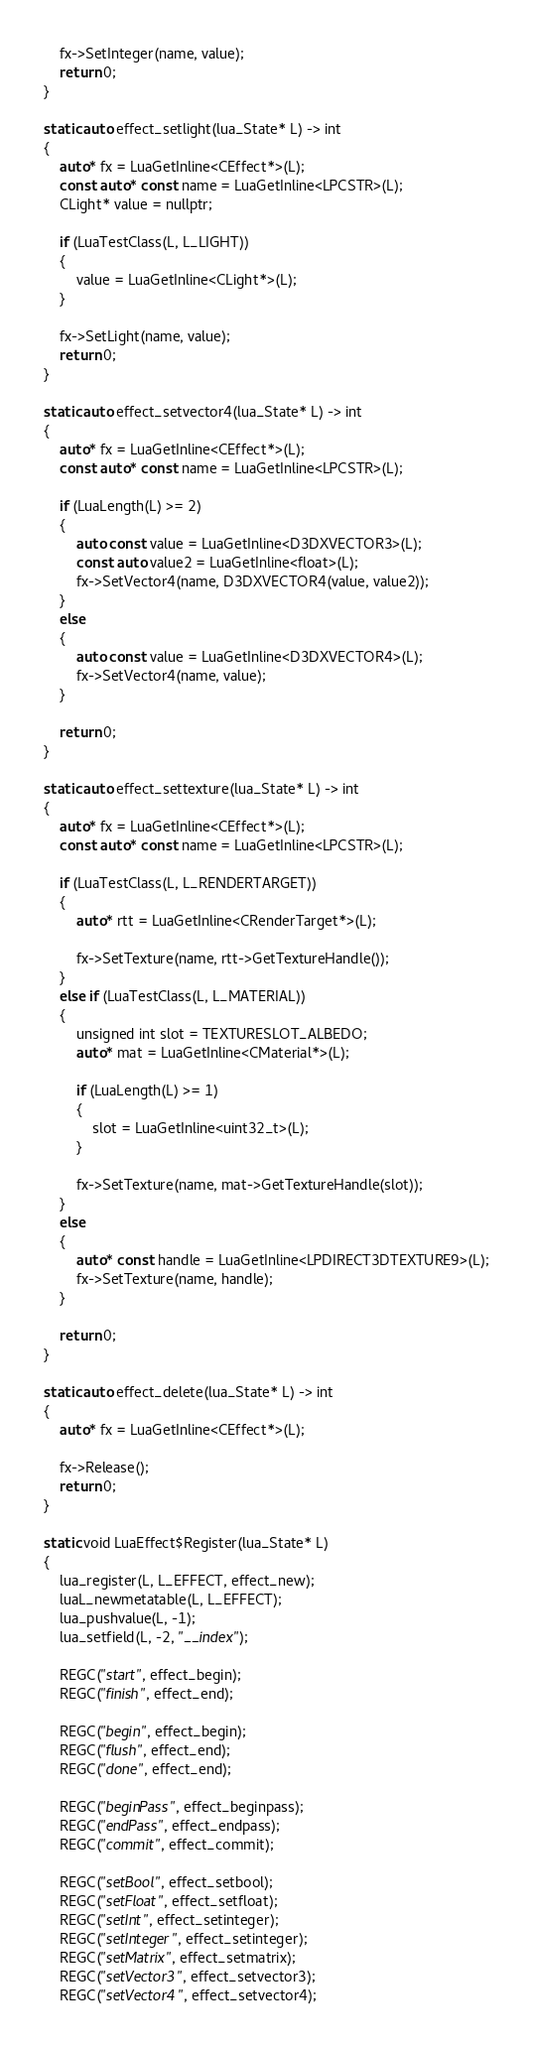Convert code to text. <code><loc_0><loc_0><loc_500><loc_500><_C_>
    fx->SetInteger(name, value);
    return 0;
}

static auto effect_setlight(lua_State* L) -> int
{
    auto* fx = LuaGetInline<CEffect*>(L);
    const auto* const name = LuaGetInline<LPCSTR>(L);
    CLight* value = nullptr;

    if (LuaTestClass(L, L_LIGHT))
    {
        value = LuaGetInline<CLight*>(L);
    }

    fx->SetLight(name, value);
    return 0;
}

static auto effect_setvector4(lua_State* L) -> int
{
    auto* fx = LuaGetInline<CEffect*>(L);
    const auto* const name = LuaGetInline<LPCSTR>(L);

    if (LuaLength(L) >= 2)
    {
        auto const value = LuaGetInline<D3DXVECTOR3>(L);
        const auto value2 = LuaGetInline<float>(L);
        fx->SetVector4(name, D3DXVECTOR4(value, value2));
    }
    else
    {
        auto const value = LuaGetInline<D3DXVECTOR4>(L);
        fx->SetVector4(name, value);
    }

    return 0;
}

static auto effect_settexture(lua_State* L) -> int
{
    auto* fx = LuaGetInline<CEffect*>(L);
    const auto* const name = LuaGetInline<LPCSTR>(L);

    if (LuaTestClass(L, L_RENDERTARGET))
    {
        auto* rtt = LuaGetInline<CRenderTarget*>(L);

        fx->SetTexture(name, rtt->GetTextureHandle());
    }
    else if (LuaTestClass(L, L_MATERIAL))
    {
        unsigned int slot = TEXTURESLOT_ALBEDO;
        auto* mat = LuaGetInline<CMaterial*>(L);

        if (LuaLength(L) >= 1)
        {
            slot = LuaGetInline<uint32_t>(L);
        }

        fx->SetTexture(name, mat->GetTextureHandle(slot));
    }
    else
    {
        auto* const handle = LuaGetInline<LPDIRECT3DTEXTURE9>(L);
        fx->SetTexture(name, handle);
    }

    return 0;
}

static auto effect_delete(lua_State* L) -> int
{
    auto* fx = LuaGetInline<CEffect*>(L);

    fx->Release();
    return 0;
}

static void LuaEffect$Register(lua_State* L)
{
    lua_register(L, L_EFFECT, effect_new);
    luaL_newmetatable(L, L_EFFECT);
    lua_pushvalue(L, -1);
    lua_setfield(L, -2, "__index");

    REGC("start", effect_begin);
    REGC("finish", effect_end);

    REGC("begin", effect_begin);
    REGC("flush", effect_end);
    REGC("done", effect_end);

    REGC("beginPass", effect_beginpass);
    REGC("endPass", effect_endpass);
    REGC("commit", effect_commit);

    REGC("setBool", effect_setbool);
    REGC("setFloat", effect_setfloat);
    REGC("setInt", effect_setinteger);
    REGC("setInteger", effect_setinteger);
    REGC("setMatrix", effect_setmatrix);
    REGC("setVector3", effect_setvector3);
    REGC("setVector4", effect_setvector4);</code> 